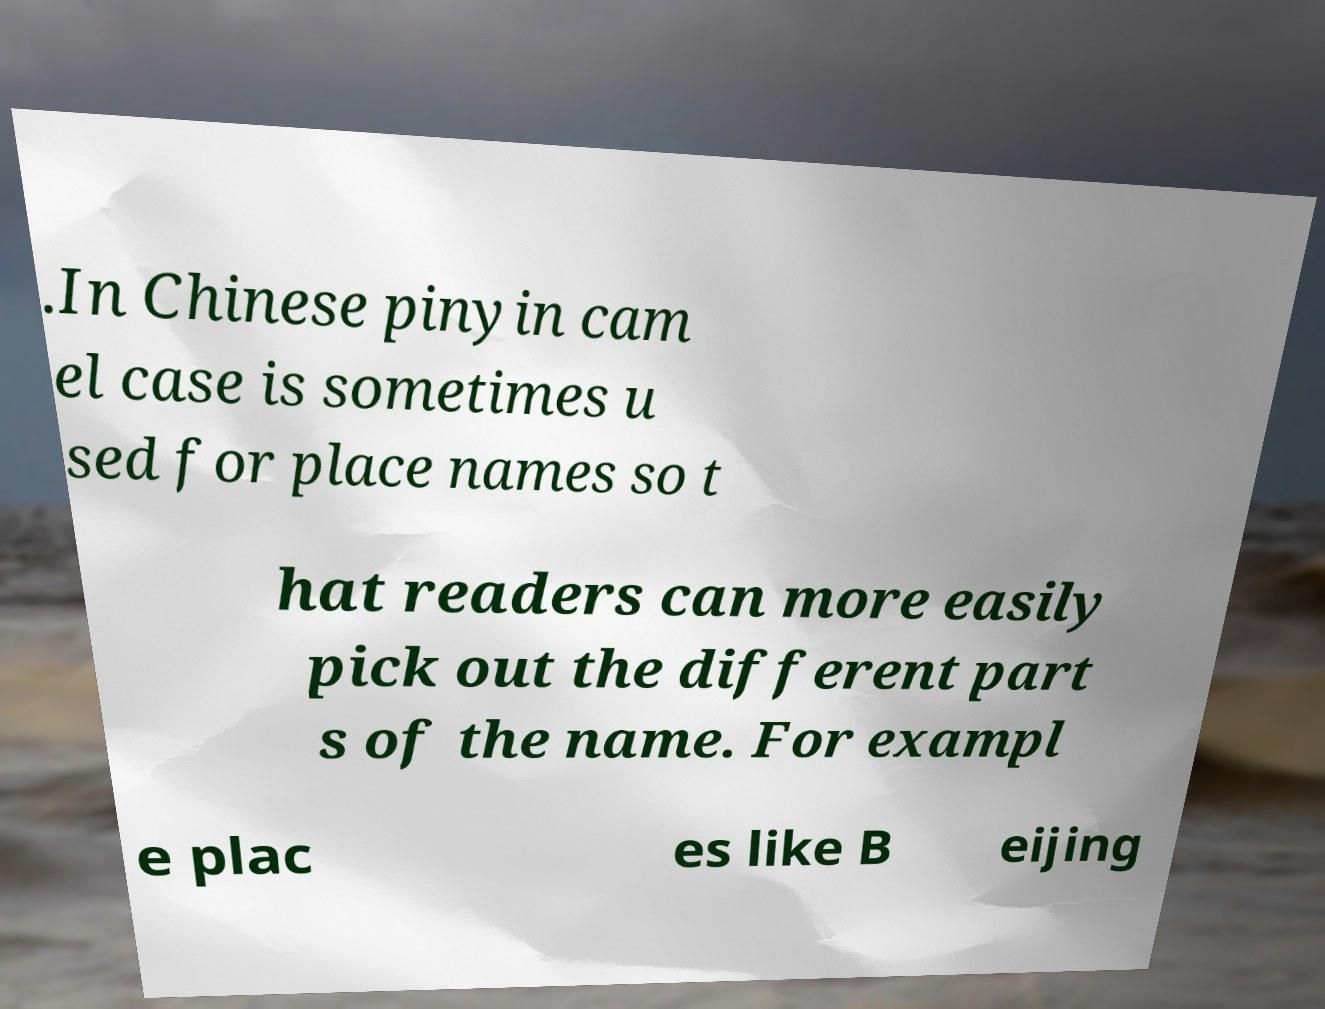Please identify and transcribe the text found in this image. .In Chinese pinyin cam el case is sometimes u sed for place names so t hat readers can more easily pick out the different part s of the name. For exampl e plac es like B eijing 